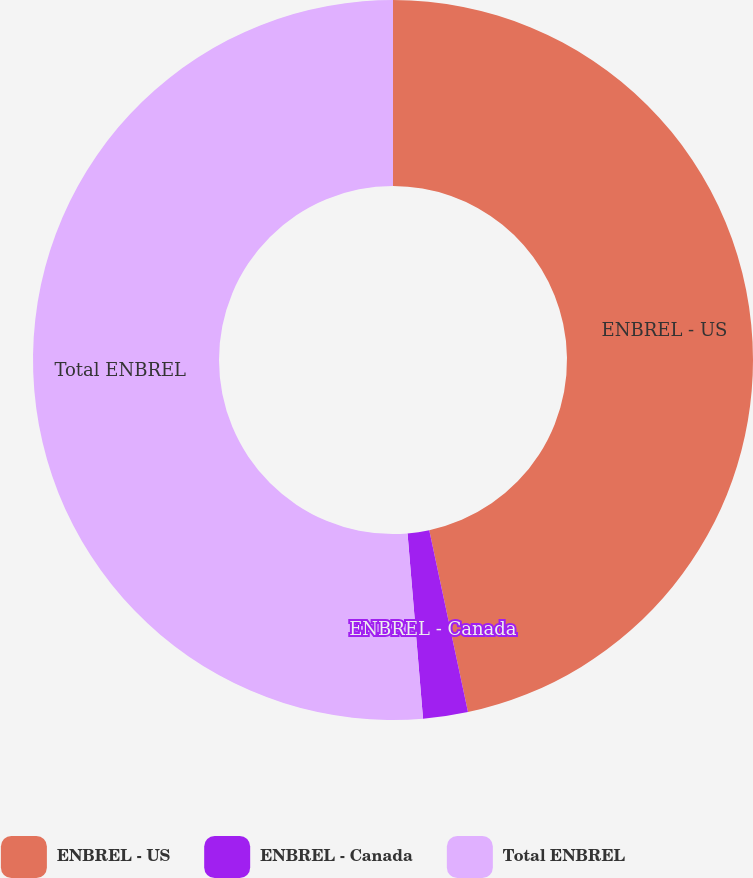Convert chart. <chart><loc_0><loc_0><loc_500><loc_500><pie_chart><fcel>ENBREL - US<fcel>ENBREL - Canada<fcel>Total ENBREL<nl><fcel>46.66%<fcel>2.01%<fcel>51.33%<nl></chart> 